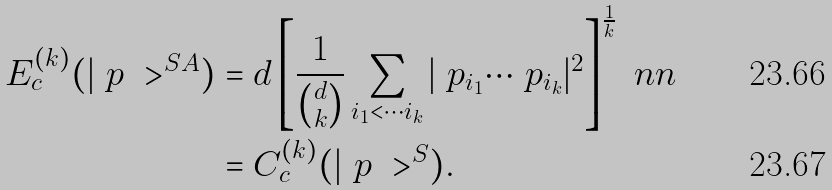Convert formula to latex. <formula><loc_0><loc_0><loc_500><loc_500>E _ { c } ^ { ( k ) } ( | \ p \ > ^ { S A } ) & = d \left [ \frac { 1 } { \binom { d } { k } } \sum _ { i _ { 1 } < \cdots i _ { k } } | \ p _ { i _ { 1 } } \cdots \ p _ { i _ { k } } | ^ { 2 } \right ] ^ { \frac { 1 } { k } } \ n n \\ & = C _ { c } ^ { ( k ) } ( | \ p \ > ^ { S } ) .</formula> 